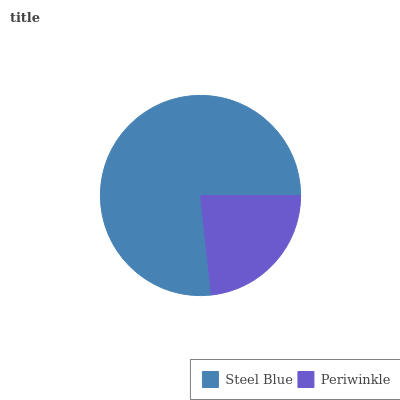Is Periwinkle the minimum?
Answer yes or no. Yes. Is Steel Blue the maximum?
Answer yes or no. Yes. Is Periwinkle the maximum?
Answer yes or no. No. Is Steel Blue greater than Periwinkle?
Answer yes or no. Yes. Is Periwinkle less than Steel Blue?
Answer yes or no. Yes. Is Periwinkle greater than Steel Blue?
Answer yes or no. No. Is Steel Blue less than Periwinkle?
Answer yes or no. No. Is Steel Blue the high median?
Answer yes or no. Yes. Is Periwinkle the low median?
Answer yes or no. Yes. Is Periwinkle the high median?
Answer yes or no. No. Is Steel Blue the low median?
Answer yes or no. No. 